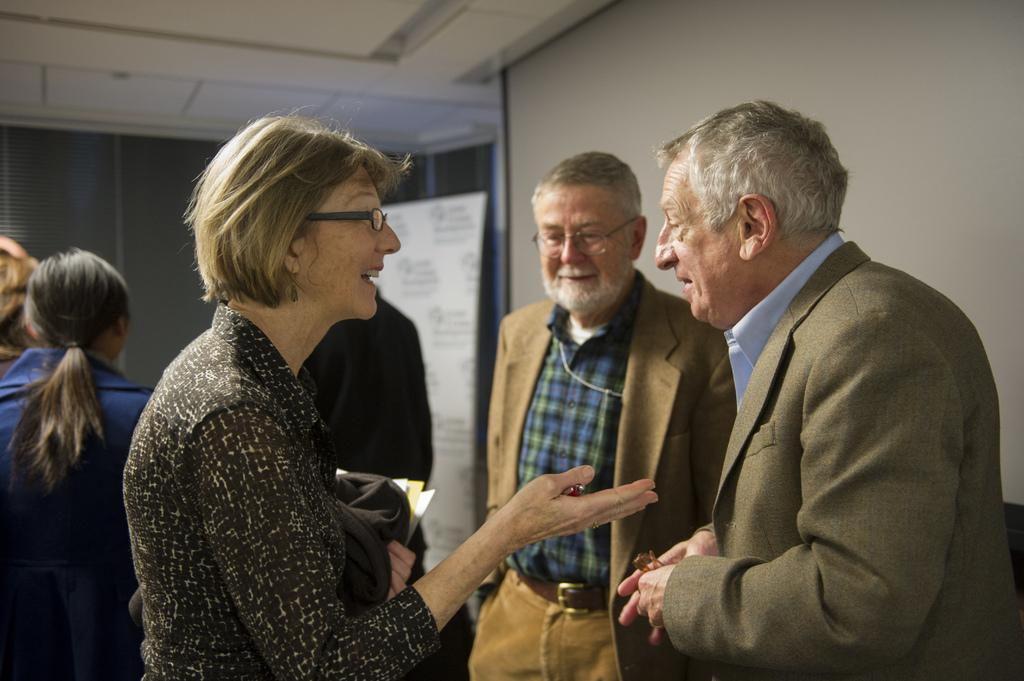How many people are visible in the image? There are three persons standing in the image. What is one of the persons holding? One person is holding papers. What can be seen in the background of the image? In the background, there are two persons standing, a board, and a wall. What type of bells can be heard ringing in the image? There are no bells present in the image, and therefore no sound can be heard. Can you see a hen in the image? There is no hen present in the image. 